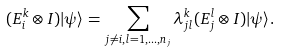Convert formula to latex. <formula><loc_0><loc_0><loc_500><loc_500>( E _ { i } ^ { k } \otimes I ) | \psi \rangle = \sum _ { j \neq i , l = 1 , \dots , n _ { j } } \lambda _ { j l } ^ { k } ( E _ { j } ^ { l } \otimes I ) | \psi \rangle .</formula> 